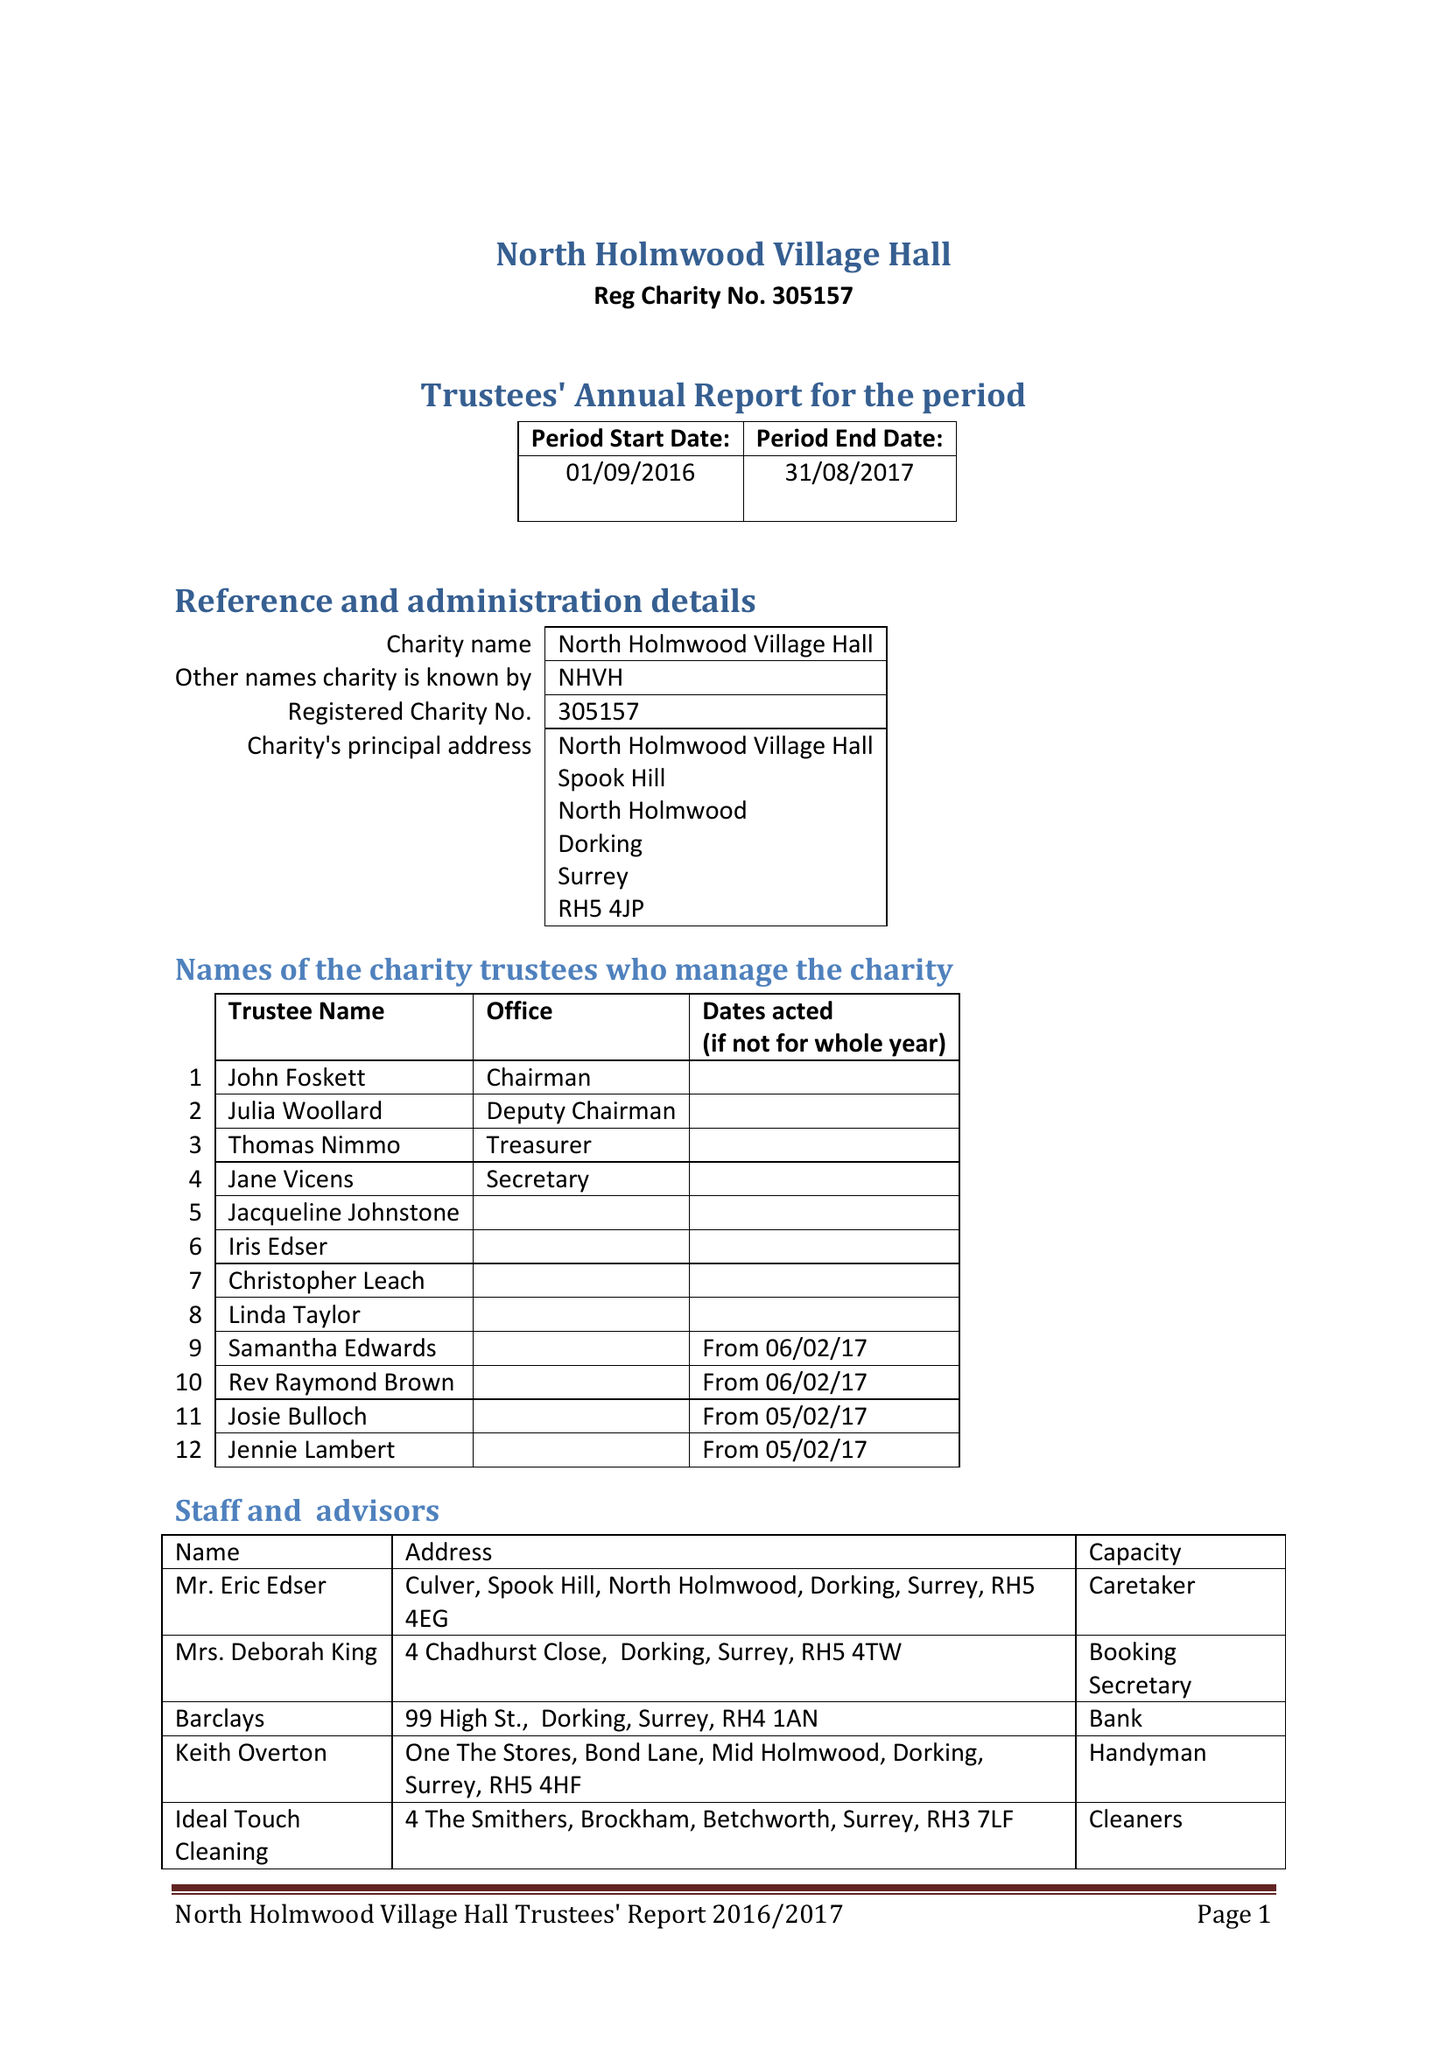What is the value for the spending_annually_in_british_pounds?
Answer the question using a single word or phrase. 28281.00 